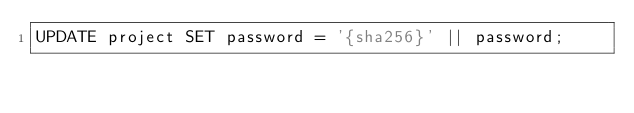Convert code to text. <code><loc_0><loc_0><loc_500><loc_500><_SQL_>UPDATE project SET password = '{sha256}' || password;</code> 